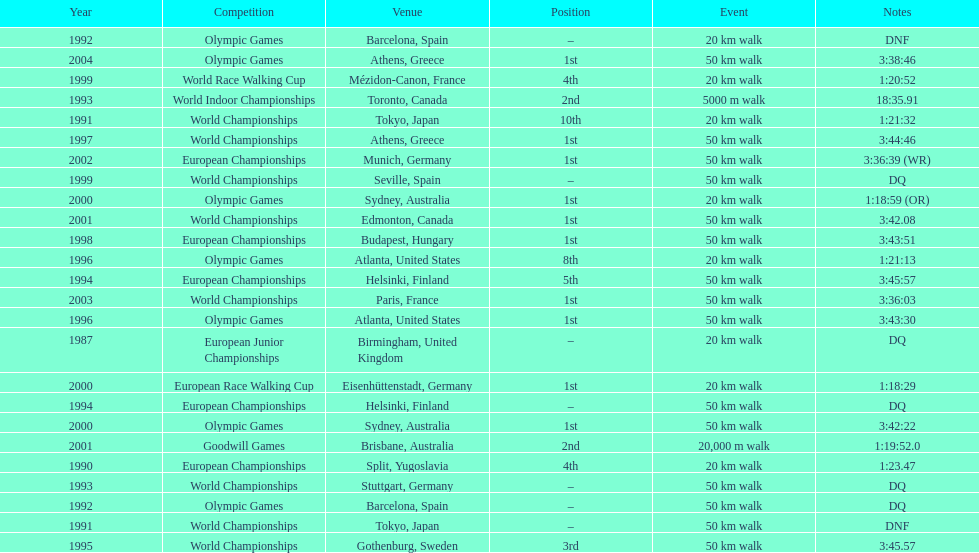What was the difference between korzeniowski's performance at the 1996 olympic games and the 2000 olympic games in the 20 km walk? 2:14. 